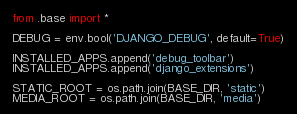<code> <loc_0><loc_0><loc_500><loc_500><_Python_>from .base import *

DEBUG = env.bool('DJANGO_DEBUG', default=True)

INSTALLED_APPS.append('debug_toolbar')
INSTALLED_APPS.append('django_extensions')

STATIC_ROOT = os.path.join(BASE_DIR, 'static')
MEDIA_ROOT = os.path.join(BASE_DIR, 'media')
</code> 